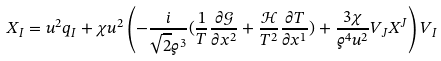Convert formula to latex. <formula><loc_0><loc_0><loc_500><loc_500>X _ { I } = u ^ { 2 } q _ { I } + { \chi u } ^ { 2 } \left ( - { \frac { i } { \sqrt { 2 } \varrho ^ { 3 } } } ( \frac { 1 } { T } { \frac { \partial \mathcal { G } } { \partial x ^ { 2 } } } + \frac { \mathcal { H } } { T ^ { 2 } } { \frac { \partial T } { \partial x ^ { 1 } } } ) + \frac { 3 \chi } { \varrho ^ { 4 } u ^ { 2 } } V _ { J } X ^ { J } \right ) V _ { I }</formula> 